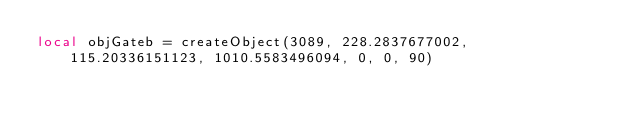Convert code to text. <code><loc_0><loc_0><loc_500><loc_500><_Lua_>local objGateb = createObject(3089, 228.2837677002, 115.20336151123, 1010.5583496094, 0, 0, 90)</code> 